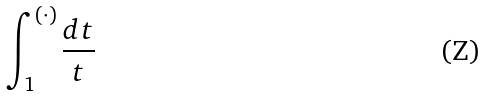<formula> <loc_0><loc_0><loc_500><loc_500>\int _ { 1 } ^ { ( \cdot ) } \frac { d t } { t }</formula> 